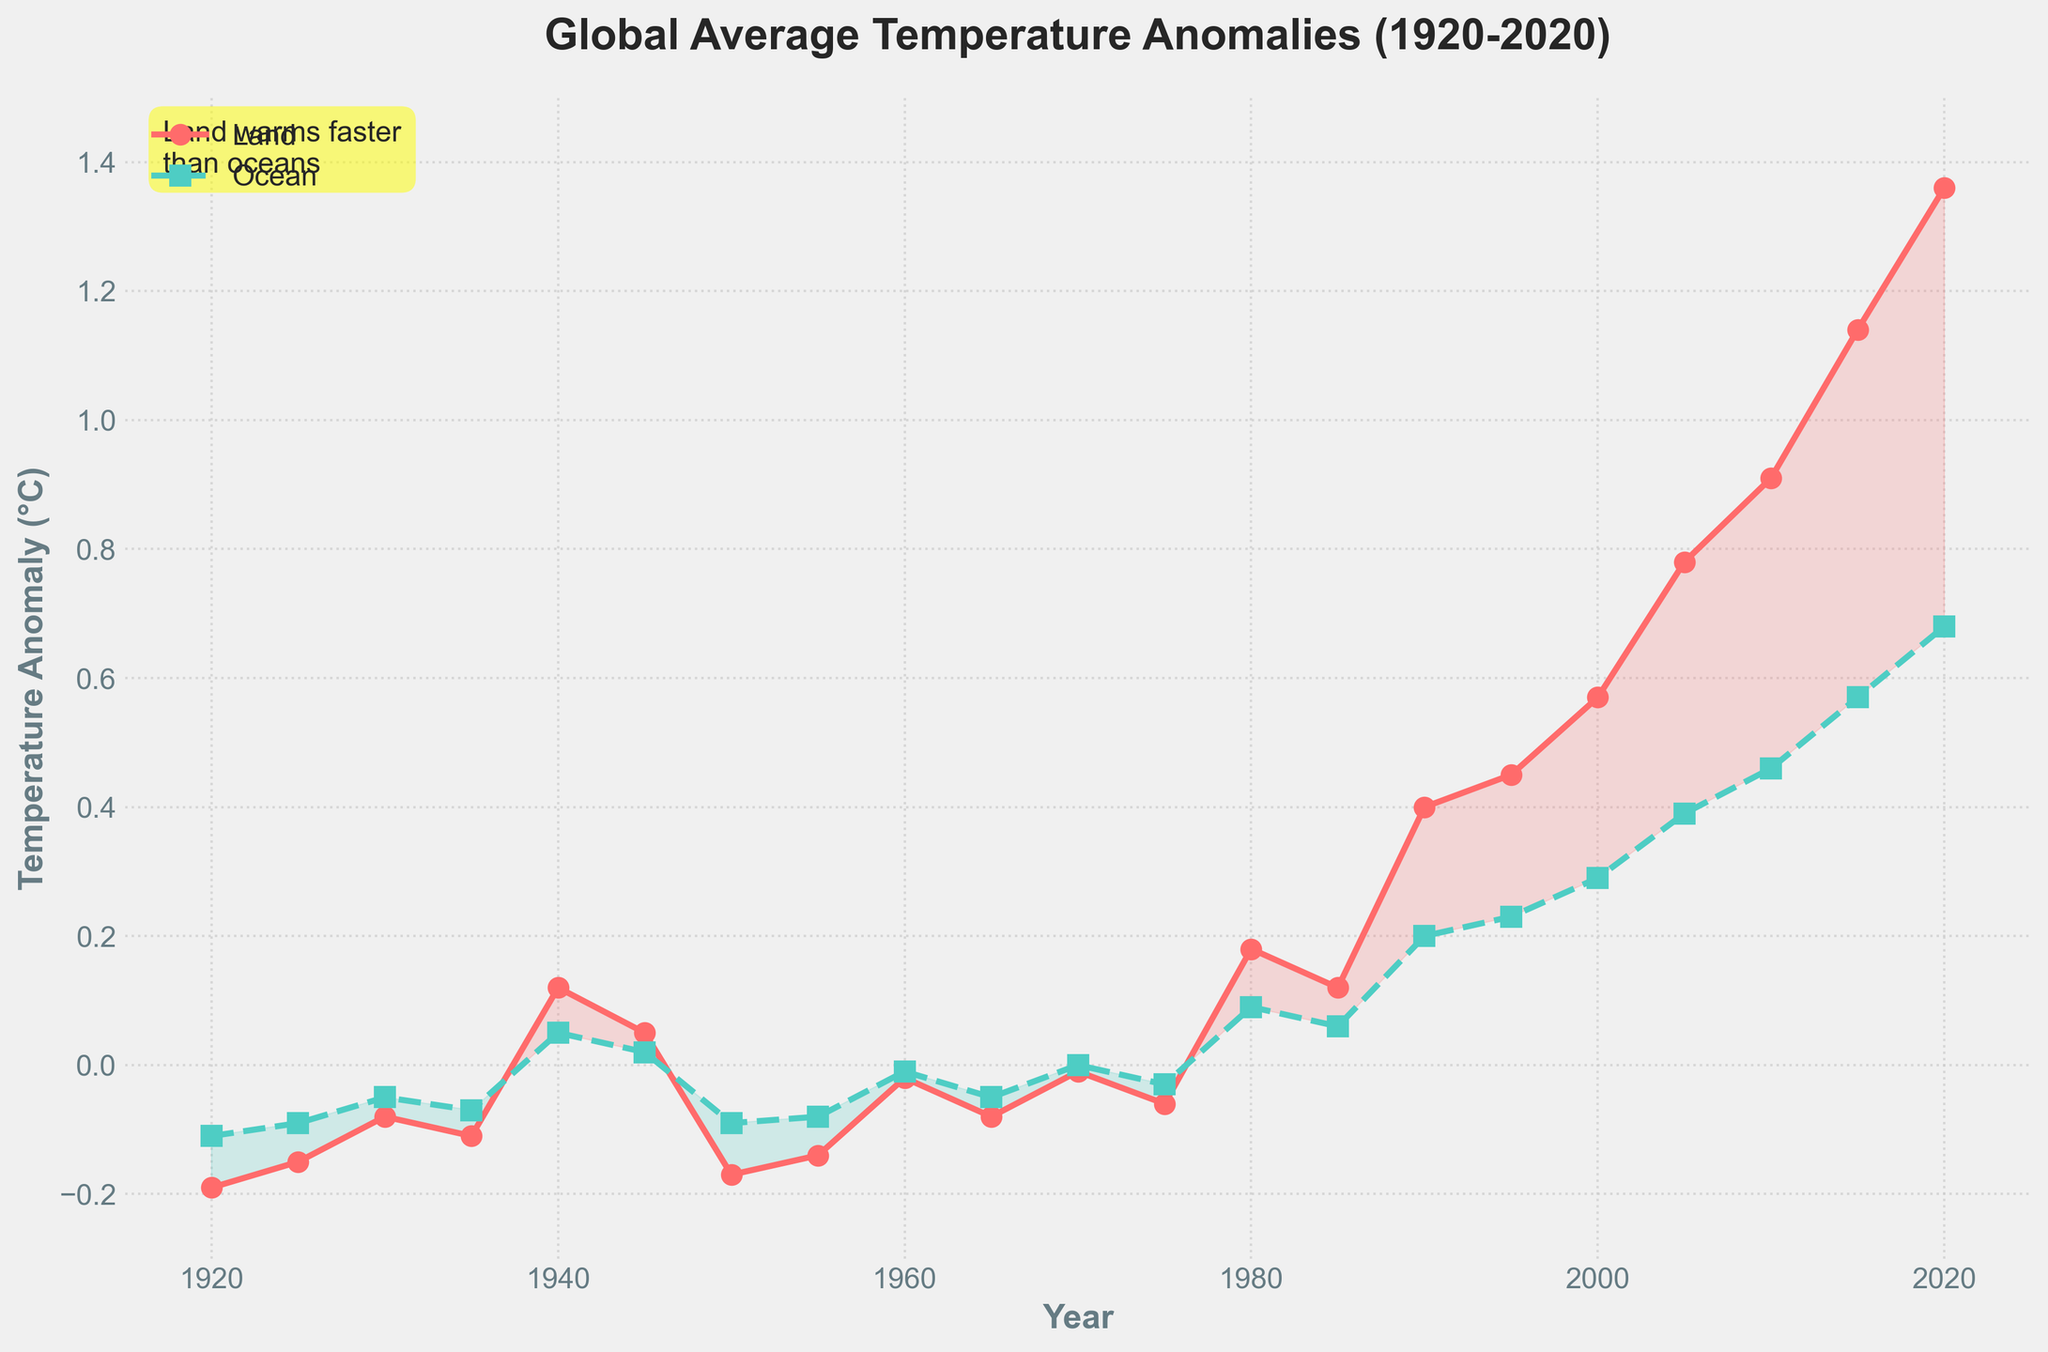How much has the land temperature anomaly increased from 1920 to 2020? The land temperature anomaly in 1920 is -0.19°C, and in 2020 it is 1.36°C. The increase is calculated as 1.36 - (-0.19) = 1.36 + 0.19 = 1.55°C
Answer: 1.55°C Which year marks the first positive anomaly in land temperature? By examining the land temperature anomalies, the first value above 0 is in 1940, with a value of 0.12°C
Answer: 1940 Compare the land and ocean temperature anomalies in 1980. Which one is larger, and by how much? In 1980, the land temperature anomaly is 0.18°C and the ocean temperature anomaly is 0.09°C. The difference is 0.18 - 0.09 = 0.09°C. The land anomaly is larger by 0.09°C
Answer: Land by 0.09°C What is the average ocean temperature anomaly for the years 2000, 2005, and 2010? The ocean temperature anomalies for these years are 0.29°C, 0.39°C, and 0.46°C respectively. The average is calculated as (0.29 + 0.39 + 0.46) / 3 = 1.14 / 3 = 0.38°C
Answer: 0.38°C Between which consecutive time periods did the land temperature anomaly show the largest increase? By calculating the differences between consecutive years, 2010 to 2015 has the largest increase: 1.14 - 0.91 = 0.23°C
Answer: 2010-2015 What is the trend in anomalies as marked by the shaded areas in the figure? The figure shows shaded areas where land temperature anomalies exceed ocean temperature anomalies in red and where ocean temperature anomalies match or exceed land temperature anomalies in green. Most of the figure's shaded areas are red, indicating that land temperatures have generally been increasing faster than ocean temperatures over time
Answer: Land warms faster than oceans If the trend continues, what might be a logical estimation of land temperature anomaly in 2025? Extrapolating the trend seen in the past, assuming about the same rate of increase observed between 2015 to 2020 (1.36 - 1.14 = 0.22°C), we estimate the anomaly in 2025 to be around 1.36 + 0.22 = 1.58°C
Answer: ~1.58°C In which decade did the ocean temperature anomaly first reach positive values? Observing the data points, the ocean temperature anomaly first became positive in the 1940s (value of 0.05°C in 1940)
Answer: 1940s 